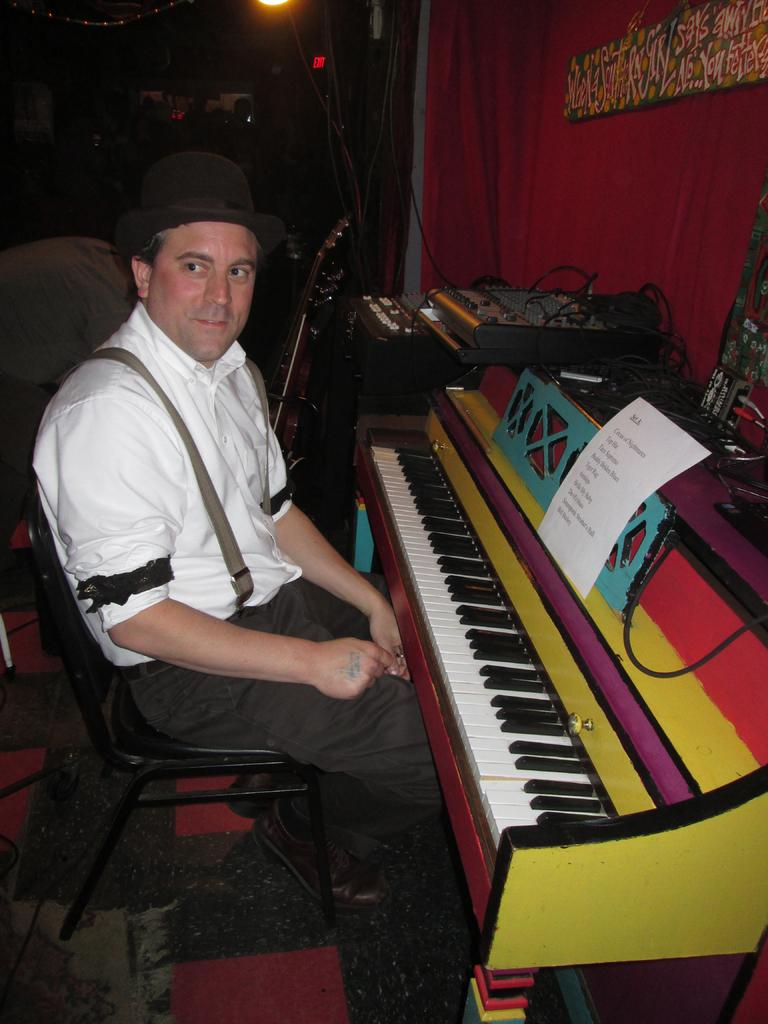Who or what is present in the image? There is a person in the image. What is the person wearing? The person is wearing clothes. What is the person doing in the image? The person is sitting on a chair. What is located behind the person? The person is in front of a piano. What can be seen in the middle of the image? There is a musical equipment in the middle of the image. What type of drug is the person holding in the image? There is no drug present in the image; the person is sitting in front of a piano and there is musical equipment in the middle of the image. 